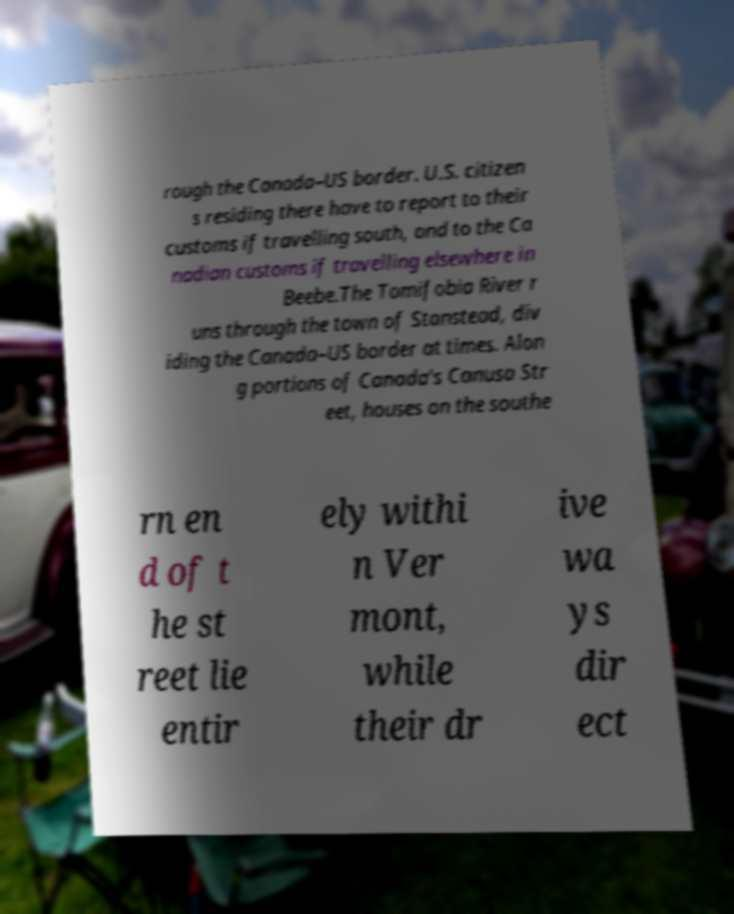Please identify and transcribe the text found in this image. rough the Canada–US border. U.S. citizen s residing there have to report to their customs if travelling south, and to the Ca nadian customs if travelling elsewhere in Beebe.The Tomifobia River r uns through the town of Stanstead, div iding the Canada–US border at times. Alon g portions of Canada's Canusa Str eet, houses on the southe rn en d of t he st reet lie entir ely withi n Ver mont, while their dr ive wa ys dir ect 